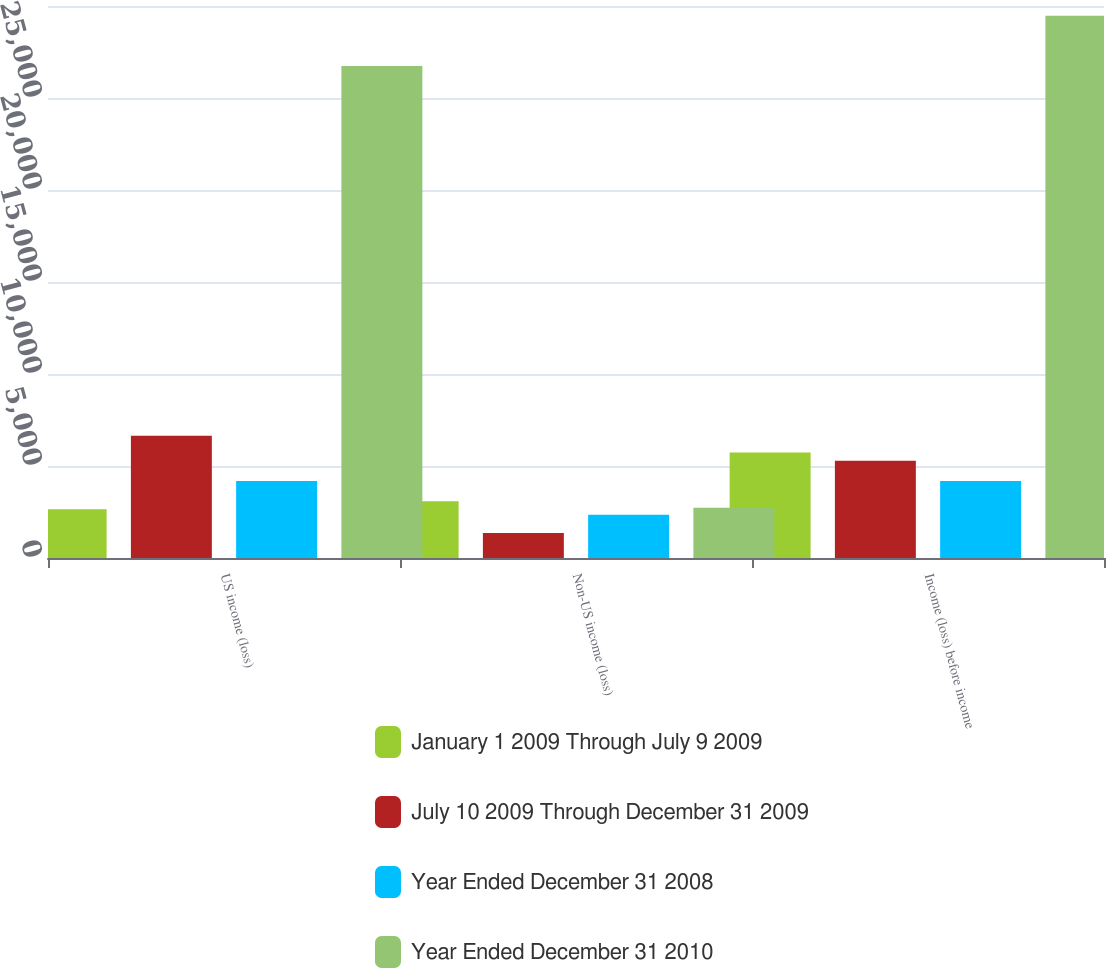Convert chart. <chart><loc_0><loc_0><loc_500><loc_500><stacked_bar_chart><ecel><fcel>US income (loss)<fcel>Non-US income (loss)<fcel>Income (loss) before income<nl><fcel>January 1 2009 Through July 9 2009<fcel>2648<fcel>3089<fcel>5737<nl><fcel>July 10 2009 Through December 31 2009<fcel>6647<fcel>1364<fcel>5283<nl><fcel>Year Ended December 31 2008<fcel>4186<fcel>2356<fcel>4186<nl><fcel>Year Ended December 31 2010<fcel>26742<fcel>2729<fcel>29471<nl></chart> 